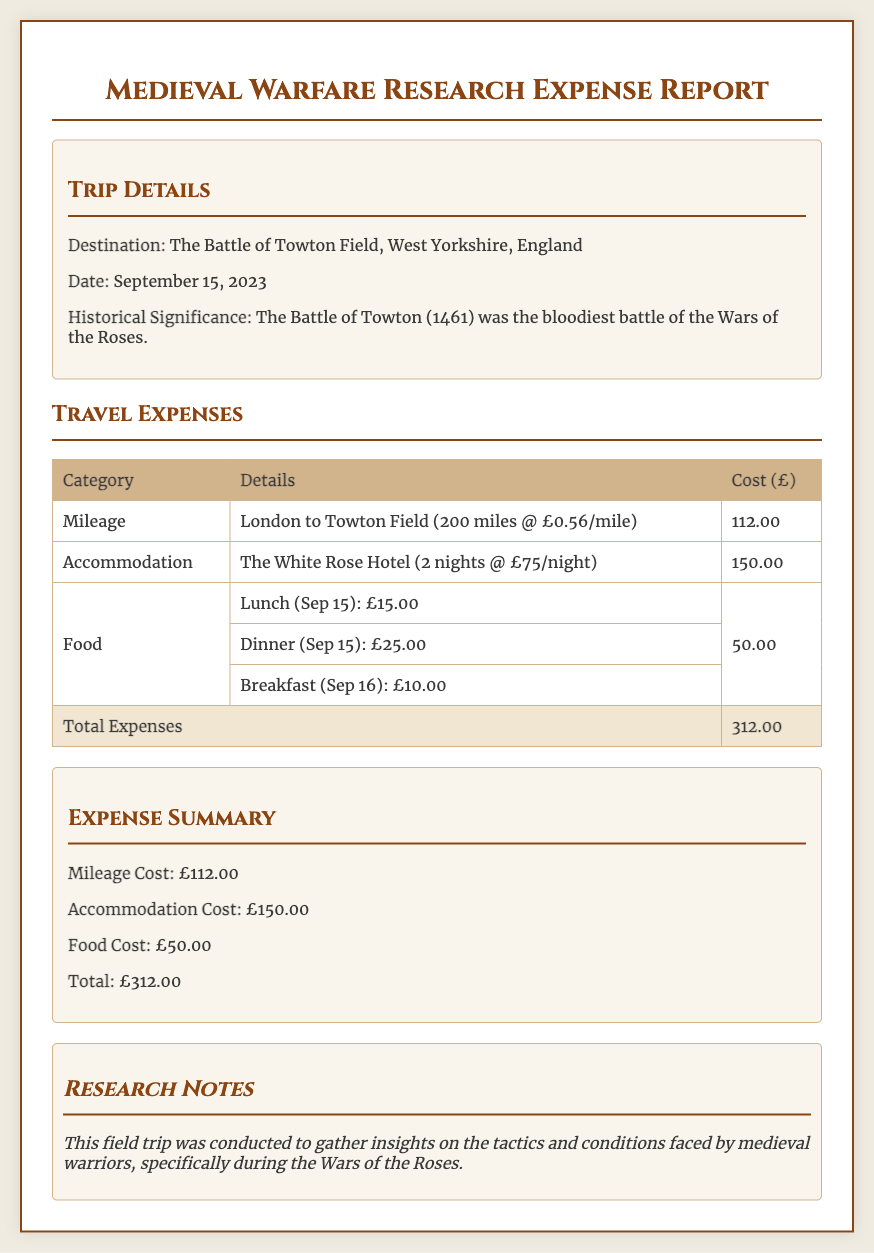What is the destination of the trip? The destination is clearly stated in the trip details section, which mentions "The Battle of Towton Field, West Yorkshire, England."
Answer: The Battle of Towton Field, West Yorkshire, England What was the date of the trip? The date can be found in the trip details section, which explicitly states "September 15, 2023."
Answer: September 15, 2023 What is the total cost of the trip? The total expenses are summarized at the bottom of the travel expenses table, showing "Total Expenses" as £312.00.
Answer: £312.00 How much was spent on accommodation? The accommodation cost is detailed in the travel expenses table, indicated specifically as "£150.00."
Answer: £150.00 What was the mileage cost? The mileage cost is detailed in the travel expenses table under the category "Mileage," which totals "£112.00."
Answer: £112.00 Why was the field trip conducted? The purpose of the field trip is outlined in the research notes section, stating it was to gather insights on "the tactics and conditions faced by medieval warriors."
Answer: To gather insights on the tactics and conditions faced by medieval warriors How many nights did the accommodation span? The accommodation details specify "2 nights" at The White Rose Hotel.
Answer: 2 nights What was the cost for dinner on September 15? The dinner cost is specifically mentioned in the food details section as "£25.00."
Answer: £25.00 What is the historical significance of the trip's destination? The historical significance is provided in the trip details, indicating it was "the bloodiest battle of the Wars of the Roses."
Answer: The bloodiest battle of the Wars of the Roses 